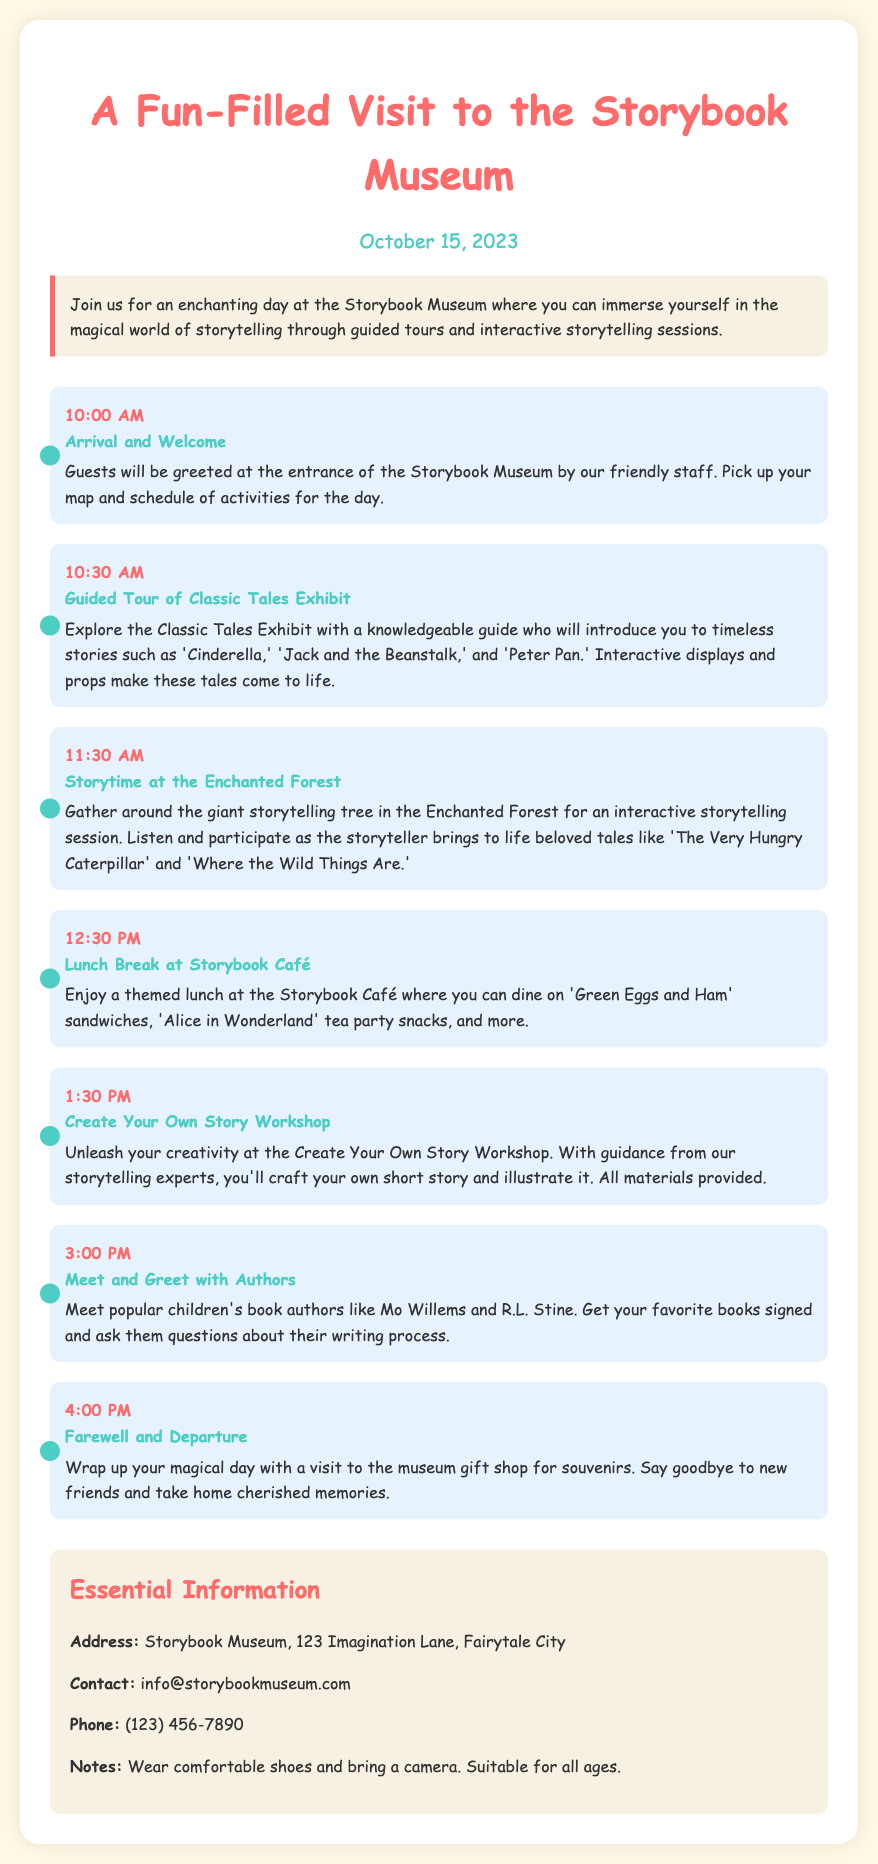What date is the visit scheduled for? The date of the visit is mentioned at the top of the document, specifically stated as October 15, 2023.
Answer: October 15, 2023 What time does the lunch break start? The lunch break is scheduled in the schedule section and is listed with its specific time, which is at 12:30 PM.
Answer: 12:30 PM Who will greet the guests at the entrance? The document states that the friendly staff will greet the guests upon arrival at the Storybook Museum.
Answer: friendly staff What activity is held at 1:30 PM? The schedule includes an activity at 1:30 PM, which is titled "Create Your Own Story Workshop."
Answer: Create Your Own Story Workshop What kind of themed lunch is offered at the café? The lunch items at the Storybook Café are mentioned in the activity description, specifying "Green Eggs and Ham" sandwiches and "Alice in Wonderland" tea party snacks.
Answer: themed lunch How many authors will guests meet during the visit? The document mentions meeting popular children’s book authors during the meet and greet, but it doesn't specify an exact number. However, it lists authors like Mo Willems and R.L. Stine as examples.
Answer: not specified What should guests bring along according to the notes? The notes section states that guests should "bring a camera."
Answer: camera What is the address of the Storybook Museum? The essential information section provides the address of the museum, which is "123 Imagination Lane, Fairytale City."
Answer: 123 Imagination Lane, Fairytale City 